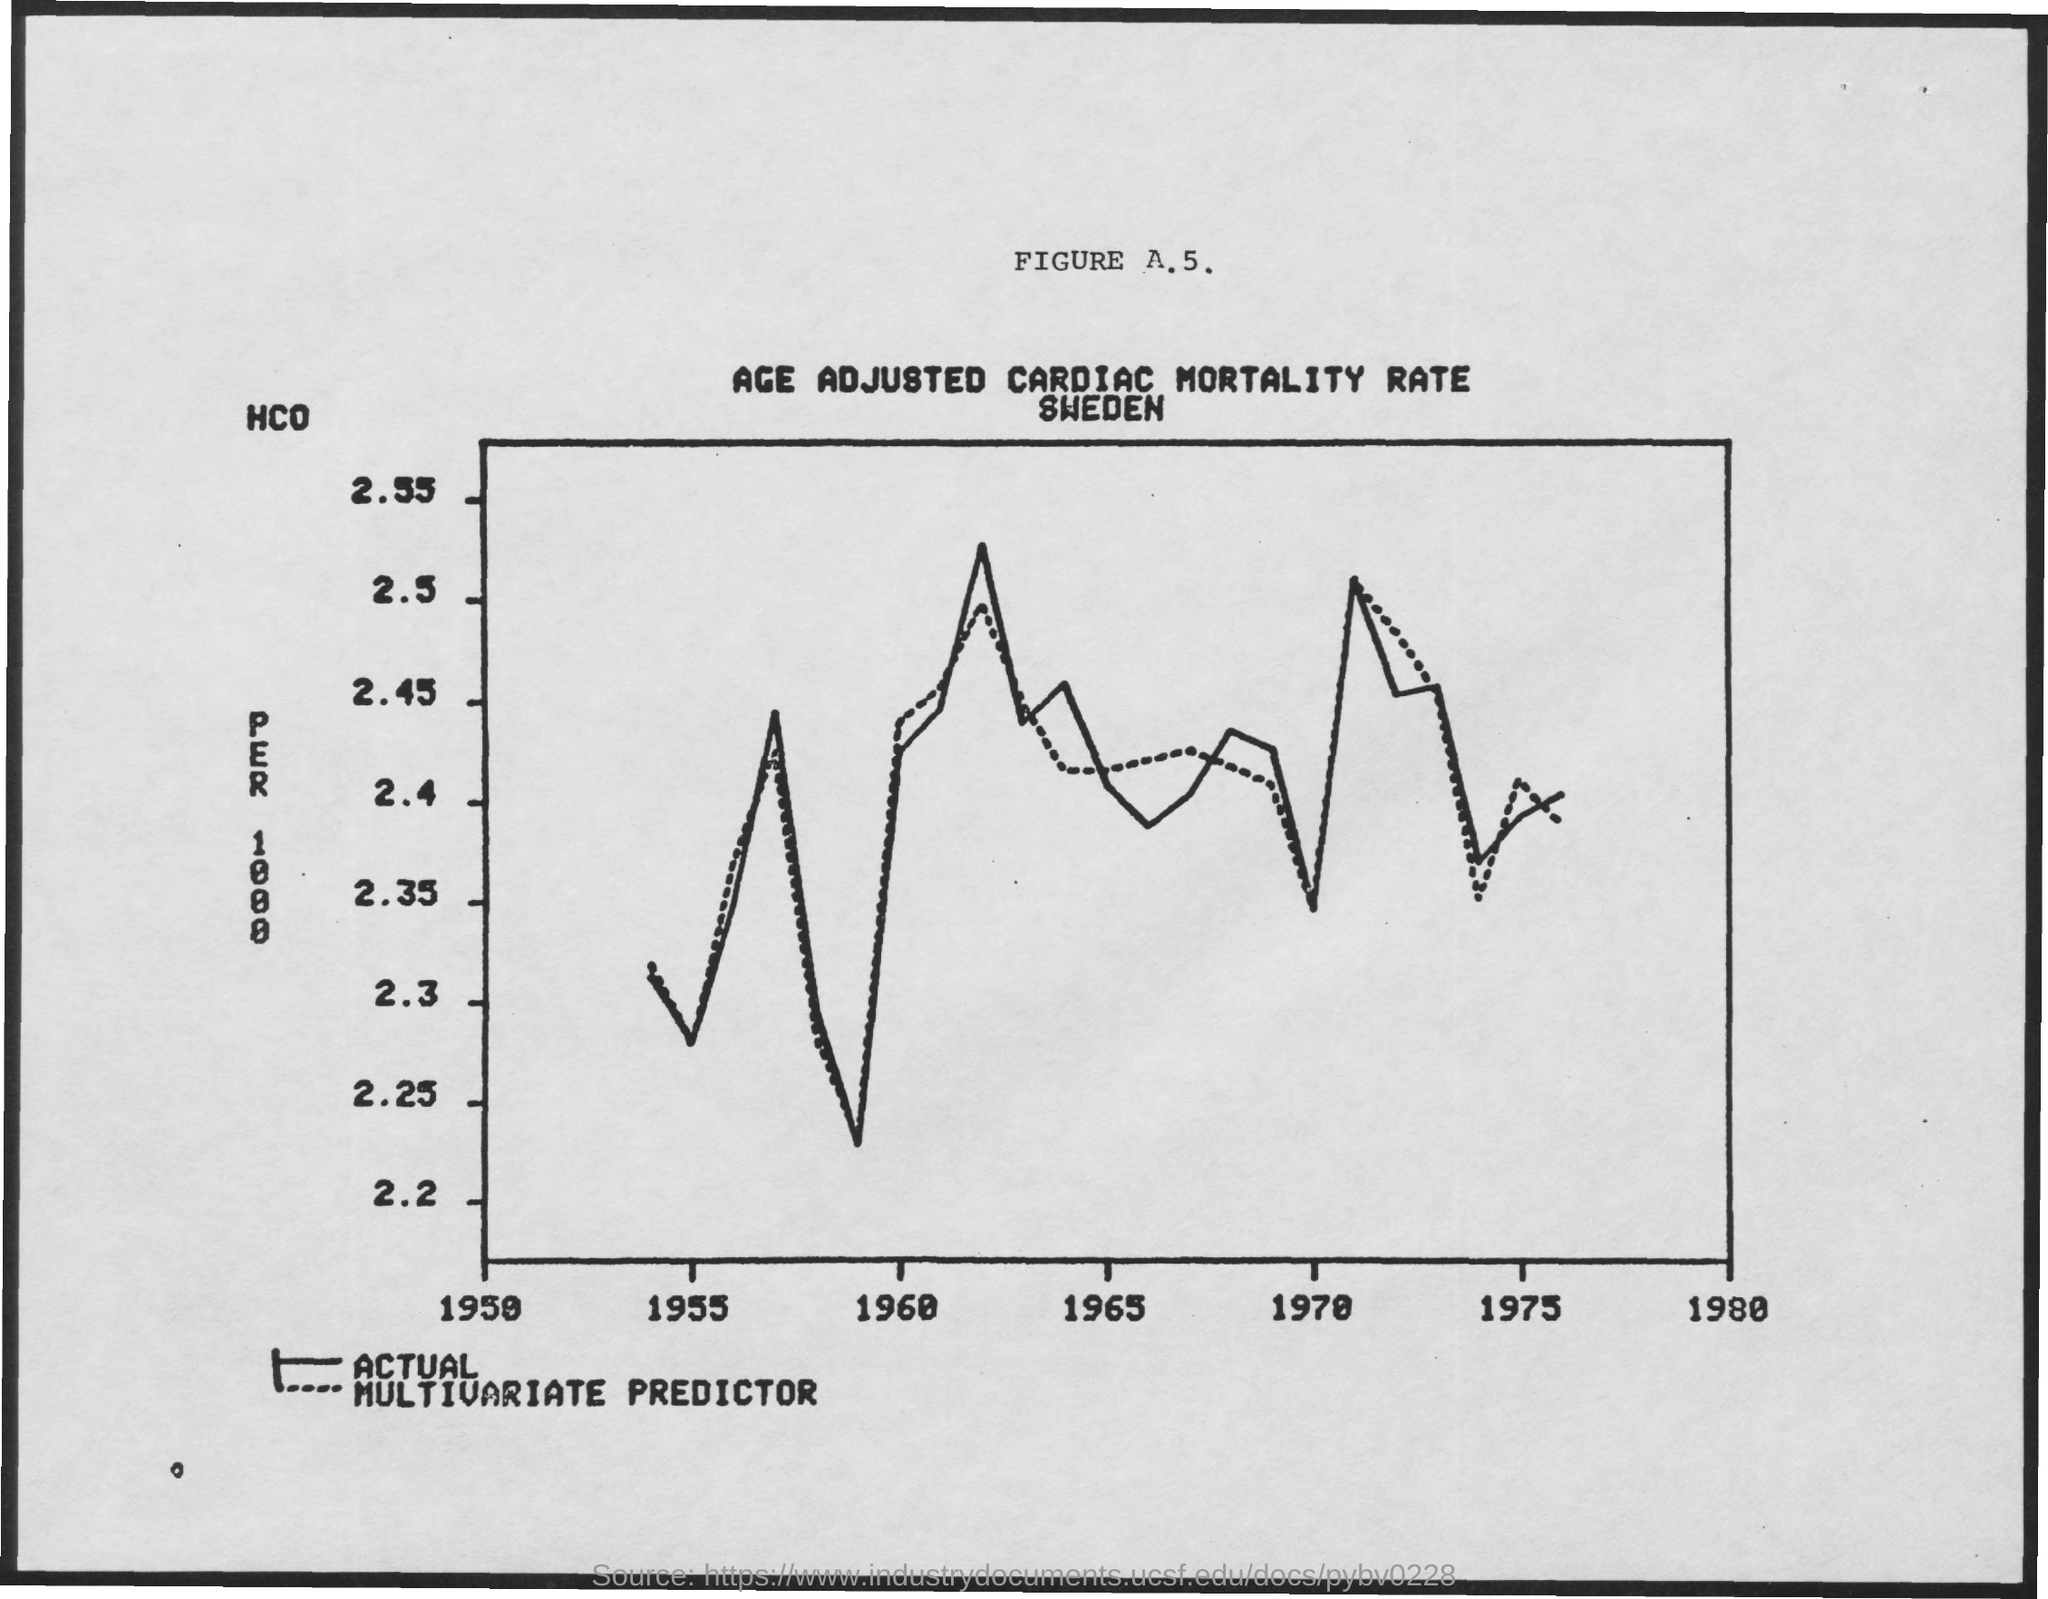What is the dotted line in the graph?
Your answer should be compact. Multivariate predictor. 